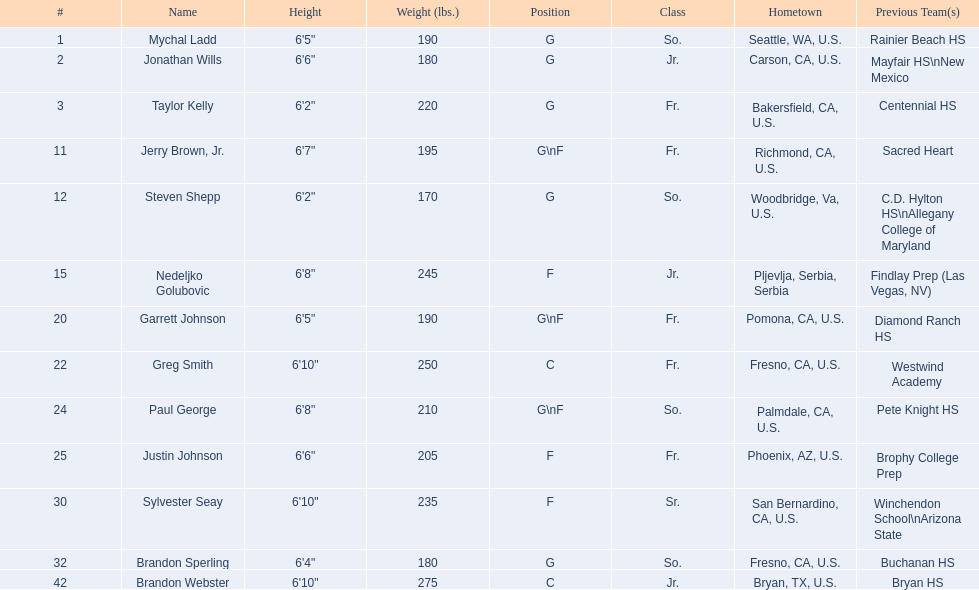Who are all the team members? Mychal Ladd, Jonathan Wills, Taylor Kelly, Jerry Brown, Jr., Steven Shepp, Nedeljko Golubovic, Garrett Johnson, Greg Smith, Paul George, Justin Johnson, Sylvester Seay, Brandon Sperling, Brandon Webster. What are their respective heights? 6'5", 6'6", 6'2", 6'7", 6'2", 6'8", 6'5", 6'10", 6'8", 6'6", 6'10", 6'4", 6'10". Besides taylor kelly, who else is under 6'3 in height? Steven Shepp. 